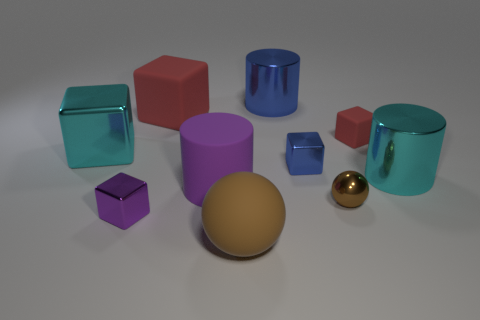How many other objects are there of the same color as the tiny rubber object?
Provide a succinct answer. 1. What material is the tiny red block that is in front of the large metal cylinder that is behind the shiny cylinder in front of the cyan metallic cube?
Ensure brevity in your answer.  Rubber. Are there any objects of the same size as the blue metallic cube?
Your response must be concise. Yes. There is a big shiny cylinder that is behind the big cyan object on the left side of the large matte sphere; what is its color?
Your answer should be very brief. Blue. What number of purple objects are there?
Provide a succinct answer. 2. Does the small sphere have the same color as the matte ball?
Your response must be concise. Yes. Is the number of big shiny cylinders on the left side of the purple metal cube less than the number of large blue things that are on the right side of the large cyan cube?
Make the answer very short. Yes. The rubber cylinder has what color?
Offer a terse response. Purple. How many tiny metal objects are the same color as the small matte object?
Provide a short and direct response. 0. There is a tiny purple metal object; are there any spheres in front of it?
Offer a very short reply. Yes. 